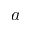Convert formula to latex. <formula><loc_0><loc_0><loc_500><loc_500>a</formula> 